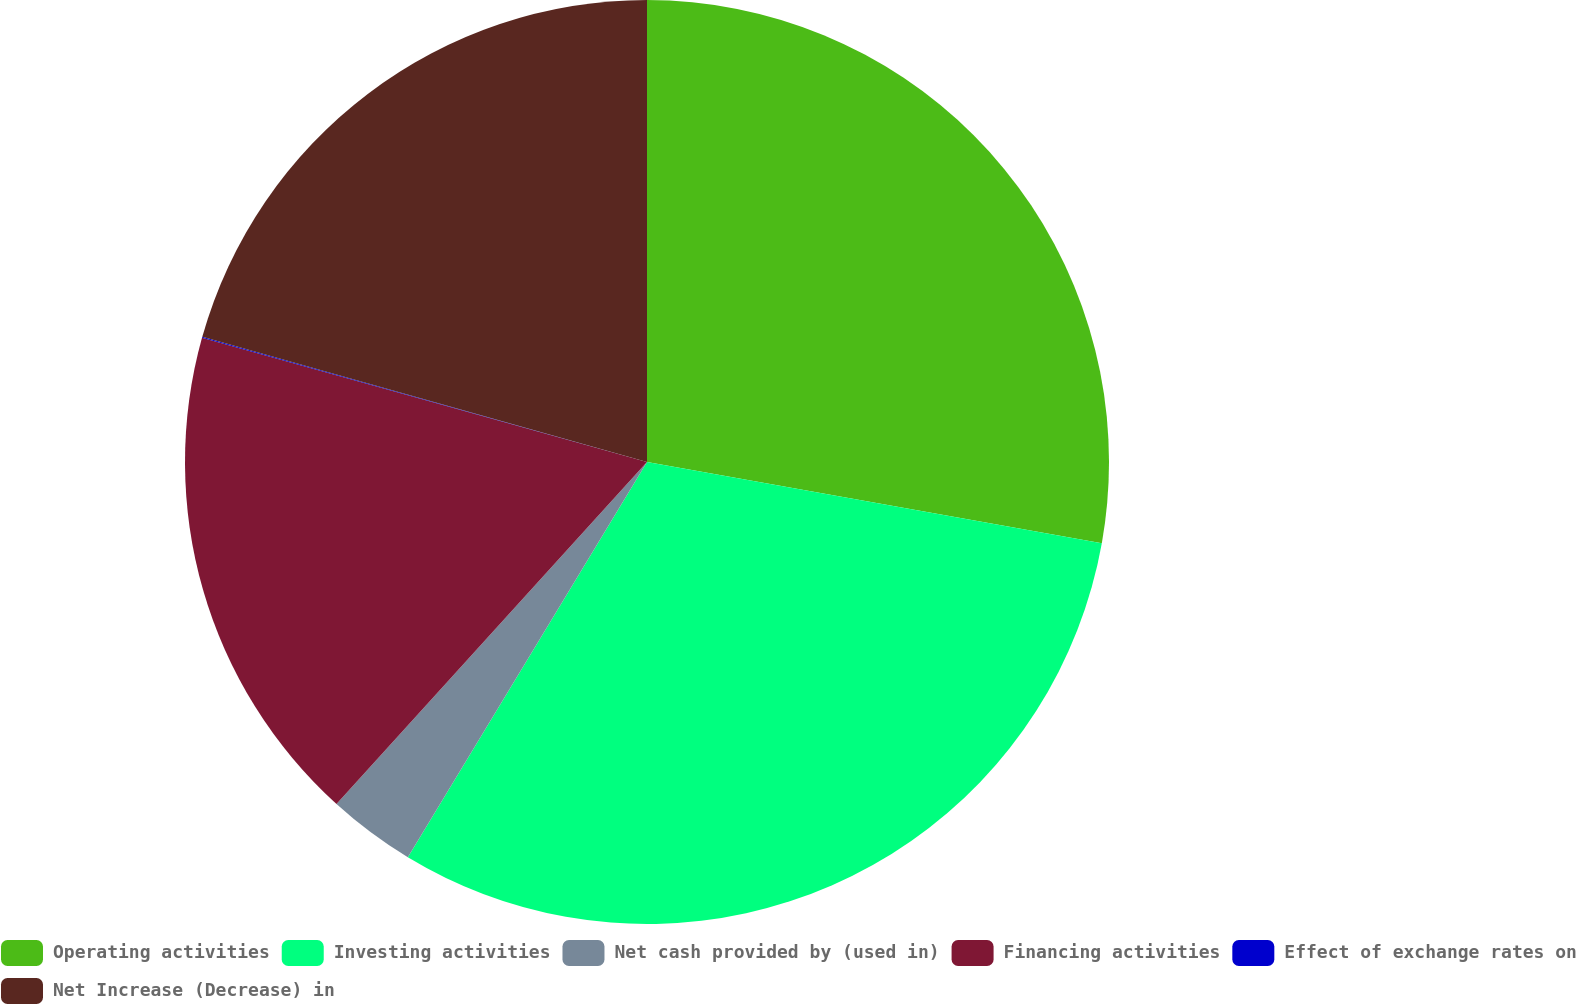Convert chart to OTSL. <chart><loc_0><loc_0><loc_500><loc_500><pie_chart><fcel>Operating activities<fcel>Investing activities<fcel>Net cash provided by (used in)<fcel>Financing activities<fcel>Effect of exchange rates on<fcel>Net Increase (Decrease) in<nl><fcel>27.81%<fcel>30.85%<fcel>3.07%<fcel>17.6%<fcel>0.04%<fcel>20.63%<nl></chart> 